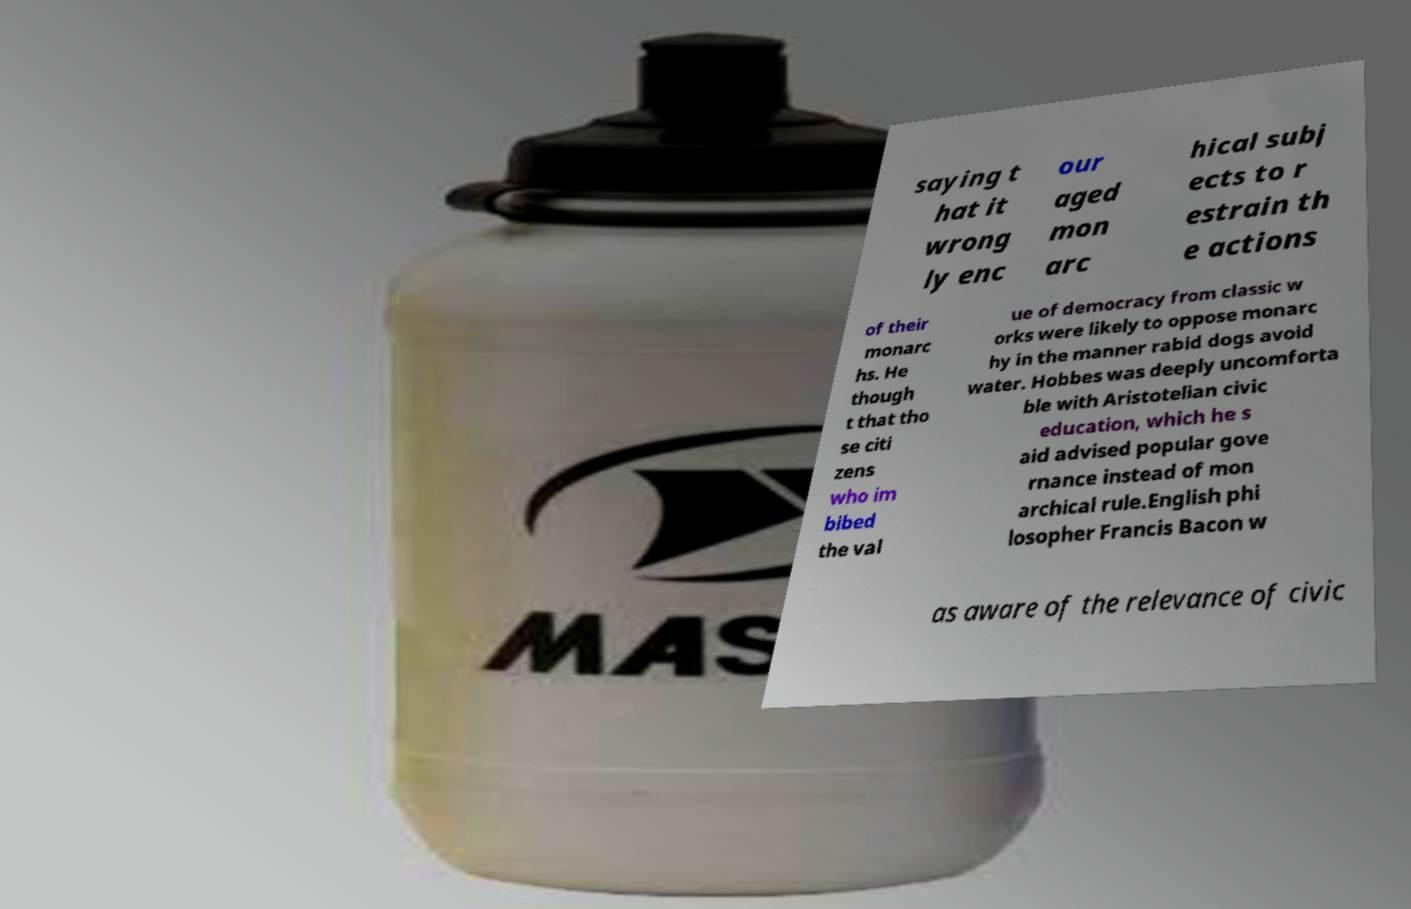What messages or text are displayed in this image? I need them in a readable, typed format. saying t hat it wrong ly enc our aged mon arc hical subj ects to r estrain th e actions of their monarc hs. He though t that tho se citi zens who im bibed the val ue of democracy from classic w orks were likely to oppose monarc hy in the manner rabid dogs avoid water. Hobbes was deeply uncomforta ble with Aristotelian civic education, which he s aid advised popular gove rnance instead of mon archical rule.English phi losopher Francis Bacon w as aware of the relevance of civic 